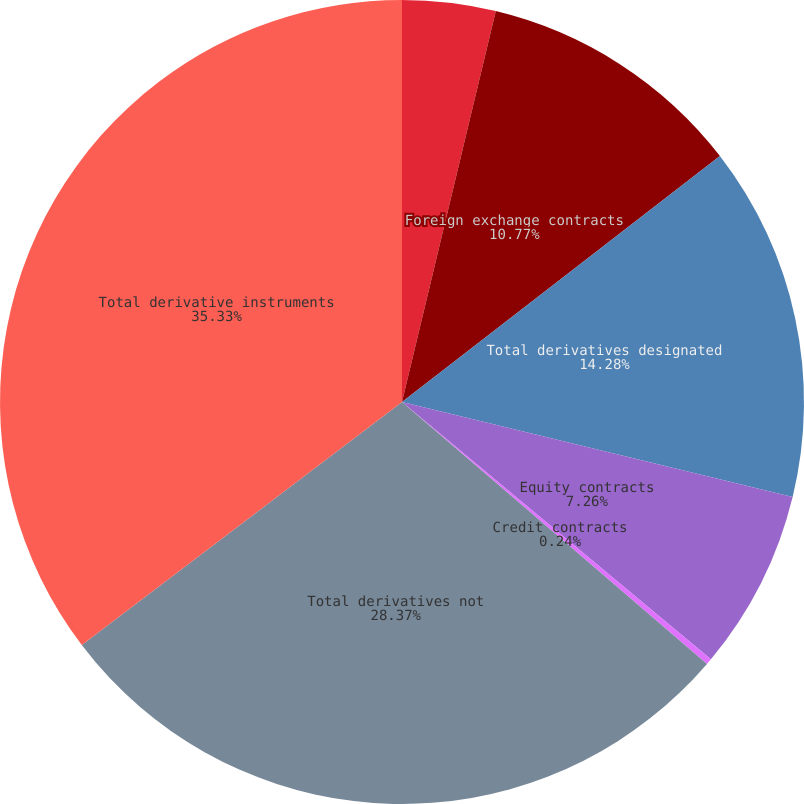Convert chart. <chart><loc_0><loc_0><loc_500><loc_500><pie_chart><fcel>Interest rate contracts<fcel>Foreign exchange contracts<fcel>Total derivatives designated<fcel>Equity contracts<fcel>Credit contracts<fcel>Total derivatives not<fcel>Total derivative instruments<nl><fcel>3.75%<fcel>10.77%<fcel>14.28%<fcel>7.26%<fcel>0.24%<fcel>28.38%<fcel>35.34%<nl></chart> 